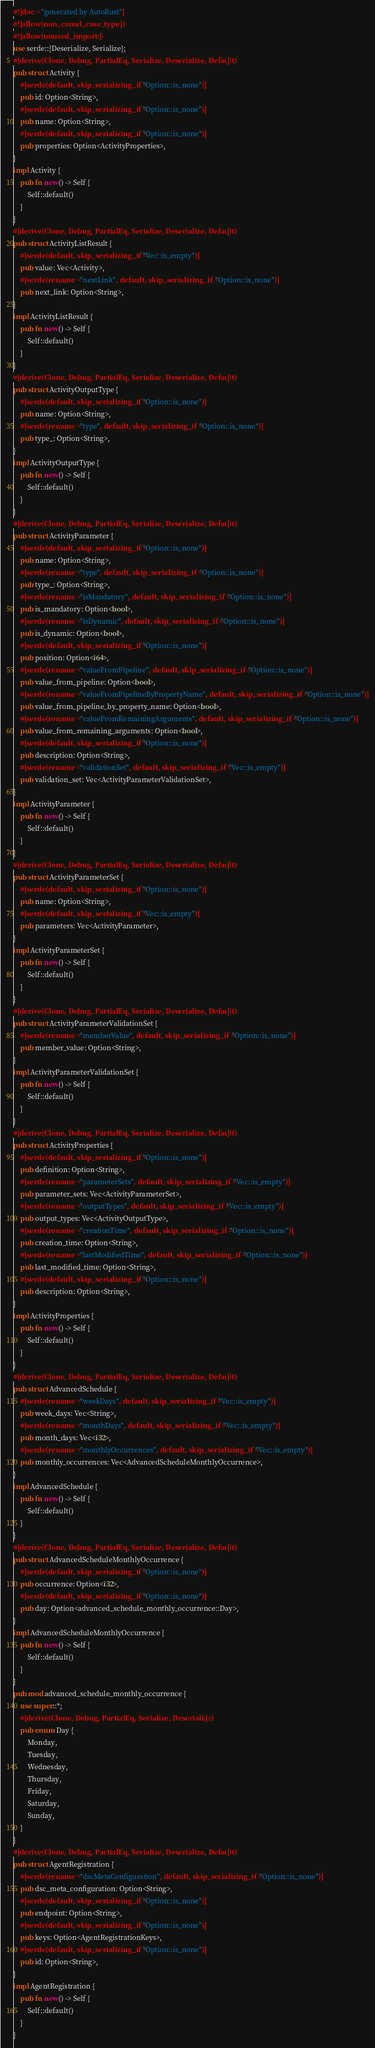Convert code to text. <code><loc_0><loc_0><loc_500><loc_500><_Rust_>#![doc = "generated by AutoRust"]
#![allow(non_camel_case_types)]
#![allow(unused_imports)]
use serde::{Deserialize, Serialize};
#[derive(Clone, Debug, PartialEq, Serialize, Deserialize, Default)]
pub struct Activity {
    #[serde(default, skip_serializing_if = "Option::is_none")]
    pub id: Option<String>,
    #[serde(default, skip_serializing_if = "Option::is_none")]
    pub name: Option<String>,
    #[serde(default, skip_serializing_if = "Option::is_none")]
    pub properties: Option<ActivityProperties>,
}
impl Activity {
    pub fn new() -> Self {
        Self::default()
    }
}
#[derive(Clone, Debug, PartialEq, Serialize, Deserialize, Default)]
pub struct ActivityListResult {
    #[serde(default, skip_serializing_if = "Vec::is_empty")]
    pub value: Vec<Activity>,
    #[serde(rename = "nextLink", default, skip_serializing_if = "Option::is_none")]
    pub next_link: Option<String>,
}
impl ActivityListResult {
    pub fn new() -> Self {
        Self::default()
    }
}
#[derive(Clone, Debug, PartialEq, Serialize, Deserialize, Default)]
pub struct ActivityOutputType {
    #[serde(default, skip_serializing_if = "Option::is_none")]
    pub name: Option<String>,
    #[serde(rename = "type", default, skip_serializing_if = "Option::is_none")]
    pub type_: Option<String>,
}
impl ActivityOutputType {
    pub fn new() -> Self {
        Self::default()
    }
}
#[derive(Clone, Debug, PartialEq, Serialize, Deserialize, Default)]
pub struct ActivityParameter {
    #[serde(default, skip_serializing_if = "Option::is_none")]
    pub name: Option<String>,
    #[serde(rename = "type", default, skip_serializing_if = "Option::is_none")]
    pub type_: Option<String>,
    #[serde(rename = "isMandatory", default, skip_serializing_if = "Option::is_none")]
    pub is_mandatory: Option<bool>,
    #[serde(rename = "isDynamic", default, skip_serializing_if = "Option::is_none")]
    pub is_dynamic: Option<bool>,
    #[serde(default, skip_serializing_if = "Option::is_none")]
    pub position: Option<i64>,
    #[serde(rename = "valueFromPipeline", default, skip_serializing_if = "Option::is_none")]
    pub value_from_pipeline: Option<bool>,
    #[serde(rename = "valueFromPipelineByPropertyName", default, skip_serializing_if = "Option::is_none")]
    pub value_from_pipeline_by_property_name: Option<bool>,
    #[serde(rename = "valueFromRemainingArguments", default, skip_serializing_if = "Option::is_none")]
    pub value_from_remaining_arguments: Option<bool>,
    #[serde(default, skip_serializing_if = "Option::is_none")]
    pub description: Option<String>,
    #[serde(rename = "validationSet", default, skip_serializing_if = "Vec::is_empty")]
    pub validation_set: Vec<ActivityParameterValidationSet>,
}
impl ActivityParameter {
    pub fn new() -> Self {
        Self::default()
    }
}
#[derive(Clone, Debug, PartialEq, Serialize, Deserialize, Default)]
pub struct ActivityParameterSet {
    #[serde(default, skip_serializing_if = "Option::is_none")]
    pub name: Option<String>,
    #[serde(default, skip_serializing_if = "Vec::is_empty")]
    pub parameters: Vec<ActivityParameter>,
}
impl ActivityParameterSet {
    pub fn new() -> Self {
        Self::default()
    }
}
#[derive(Clone, Debug, PartialEq, Serialize, Deserialize, Default)]
pub struct ActivityParameterValidationSet {
    #[serde(rename = "memberValue", default, skip_serializing_if = "Option::is_none")]
    pub member_value: Option<String>,
}
impl ActivityParameterValidationSet {
    pub fn new() -> Self {
        Self::default()
    }
}
#[derive(Clone, Debug, PartialEq, Serialize, Deserialize, Default)]
pub struct ActivityProperties {
    #[serde(default, skip_serializing_if = "Option::is_none")]
    pub definition: Option<String>,
    #[serde(rename = "parameterSets", default, skip_serializing_if = "Vec::is_empty")]
    pub parameter_sets: Vec<ActivityParameterSet>,
    #[serde(rename = "outputTypes", default, skip_serializing_if = "Vec::is_empty")]
    pub output_types: Vec<ActivityOutputType>,
    #[serde(rename = "creationTime", default, skip_serializing_if = "Option::is_none")]
    pub creation_time: Option<String>,
    #[serde(rename = "lastModifiedTime", default, skip_serializing_if = "Option::is_none")]
    pub last_modified_time: Option<String>,
    #[serde(default, skip_serializing_if = "Option::is_none")]
    pub description: Option<String>,
}
impl ActivityProperties {
    pub fn new() -> Self {
        Self::default()
    }
}
#[derive(Clone, Debug, PartialEq, Serialize, Deserialize, Default)]
pub struct AdvancedSchedule {
    #[serde(rename = "weekDays", default, skip_serializing_if = "Vec::is_empty")]
    pub week_days: Vec<String>,
    #[serde(rename = "monthDays", default, skip_serializing_if = "Vec::is_empty")]
    pub month_days: Vec<i32>,
    #[serde(rename = "monthlyOccurrences", default, skip_serializing_if = "Vec::is_empty")]
    pub monthly_occurrences: Vec<AdvancedScheduleMonthlyOccurrence>,
}
impl AdvancedSchedule {
    pub fn new() -> Self {
        Self::default()
    }
}
#[derive(Clone, Debug, PartialEq, Serialize, Deserialize, Default)]
pub struct AdvancedScheduleMonthlyOccurrence {
    #[serde(default, skip_serializing_if = "Option::is_none")]
    pub occurrence: Option<i32>,
    #[serde(default, skip_serializing_if = "Option::is_none")]
    pub day: Option<advanced_schedule_monthly_occurrence::Day>,
}
impl AdvancedScheduleMonthlyOccurrence {
    pub fn new() -> Self {
        Self::default()
    }
}
pub mod advanced_schedule_monthly_occurrence {
    use super::*;
    #[derive(Clone, Debug, PartialEq, Serialize, Deserialize)]
    pub enum Day {
        Monday,
        Tuesday,
        Wednesday,
        Thursday,
        Friday,
        Saturday,
        Sunday,
    }
}
#[derive(Clone, Debug, PartialEq, Serialize, Deserialize, Default)]
pub struct AgentRegistration {
    #[serde(rename = "dscMetaConfiguration", default, skip_serializing_if = "Option::is_none")]
    pub dsc_meta_configuration: Option<String>,
    #[serde(default, skip_serializing_if = "Option::is_none")]
    pub endpoint: Option<String>,
    #[serde(default, skip_serializing_if = "Option::is_none")]
    pub keys: Option<AgentRegistrationKeys>,
    #[serde(default, skip_serializing_if = "Option::is_none")]
    pub id: Option<String>,
}
impl AgentRegistration {
    pub fn new() -> Self {
        Self::default()
    }
}</code> 